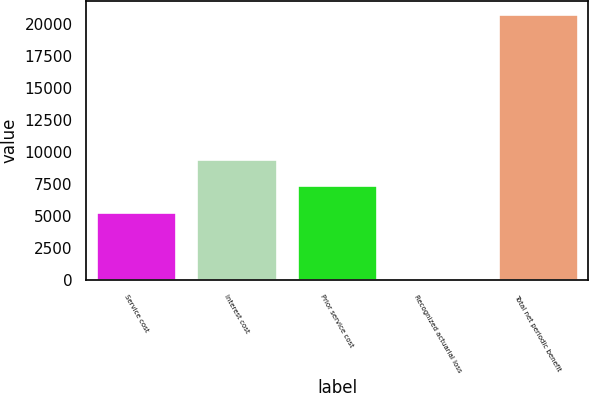Convert chart to OTSL. <chart><loc_0><loc_0><loc_500><loc_500><bar_chart><fcel>Service cost<fcel>Interest cost<fcel>Prior service cost<fcel>Recognized actuarial loss<fcel>Total net periodic benefit<nl><fcel>5304<fcel>9489.5<fcel>7425<fcel>138<fcel>20783<nl></chart> 